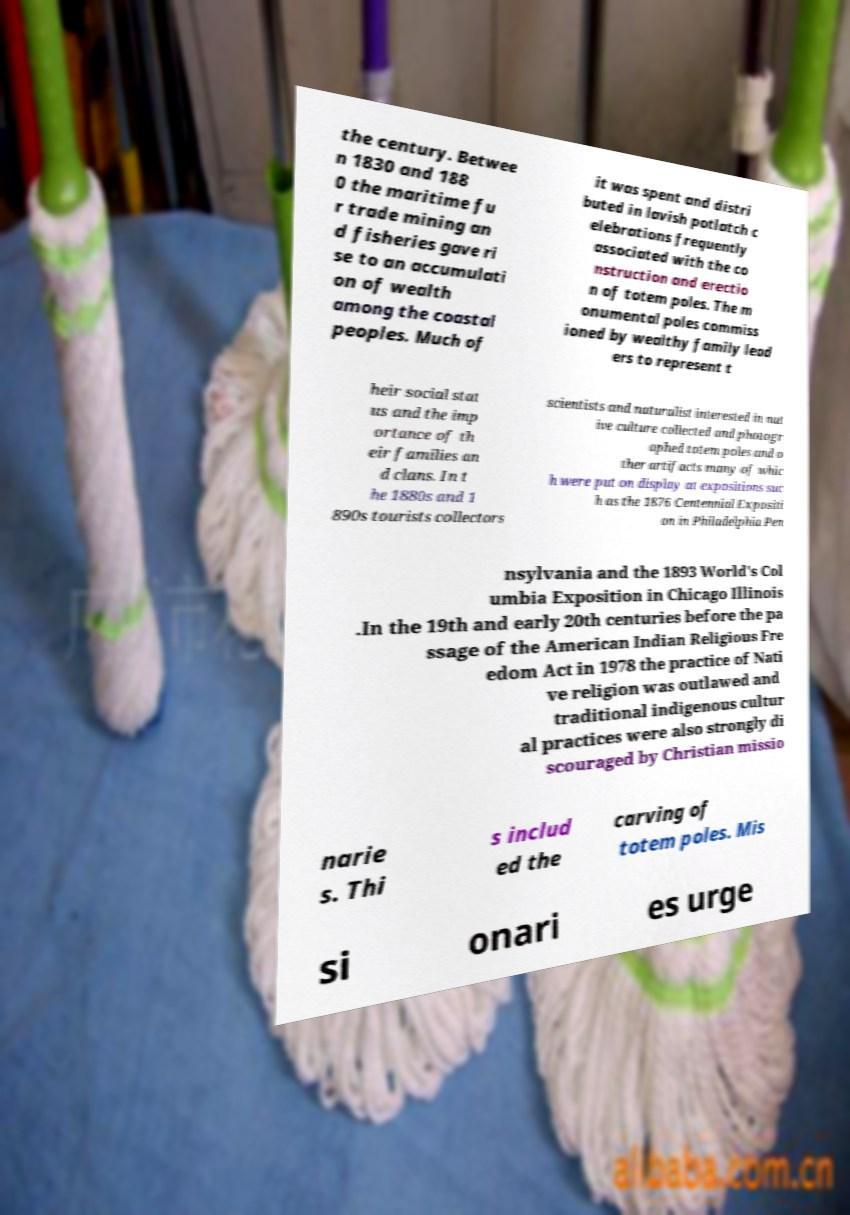There's text embedded in this image that I need extracted. Can you transcribe it verbatim? the century. Betwee n 1830 and 188 0 the maritime fu r trade mining an d fisheries gave ri se to an accumulati on of wealth among the coastal peoples. Much of it was spent and distri buted in lavish potlatch c elebrations frequently associated with the co nstruction and erectio n of totem poles. The m onumental poles commiss ioned by wealthy family lead ers to represent t heir social stat us and the imp ortance of th eir families an d clans. In t he 1880s and 1 890s tourists collectors scientists and naturalist interested in nat ive culture collected and photogr aphed totem poles and o ther artifacts many of whic h were put on display at expositions suc h as the 1876 Centennial Expositi on in Philadelphia Pen nsylvania and the 1893 World's Col umbia Exposition in Chicago Illinois .In the 19th and early 20th centuries before the pa ssage of the American Indian Religious Fre edom Act in 1978 the practice of Nati ve religion was outlawed and traditional indigenous cultur al practices were also strongly di scouraged by Christian missio narie s. Thi s includ ed the carving of totem poles. Mis si onari es urge 